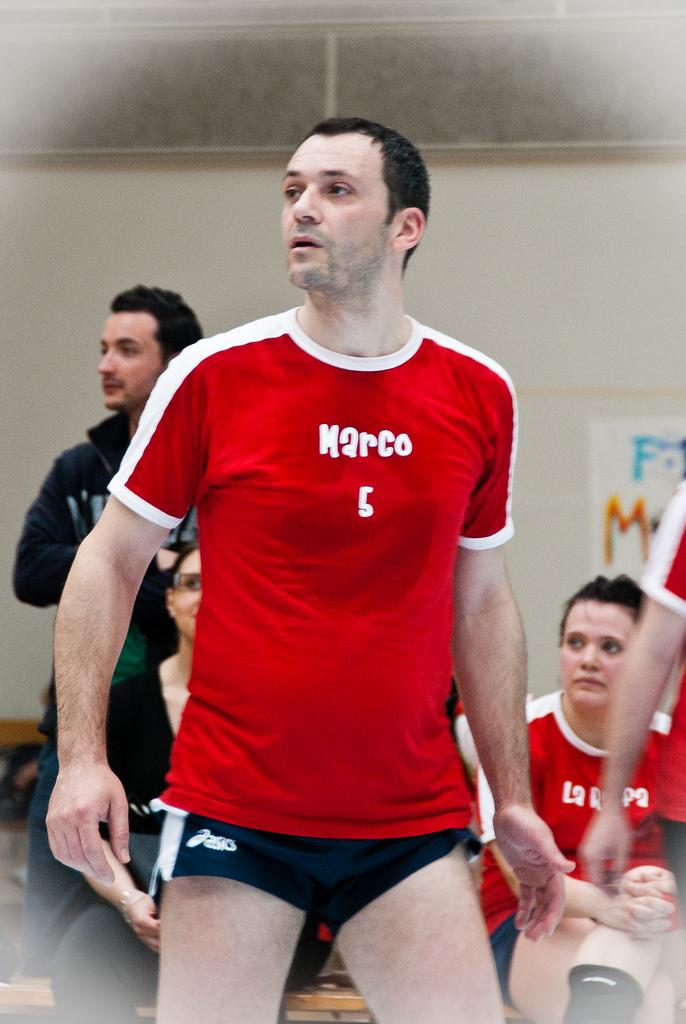Provide a one-sentence caption for the provided image. Man wearing a red shirt which says marco on it. 